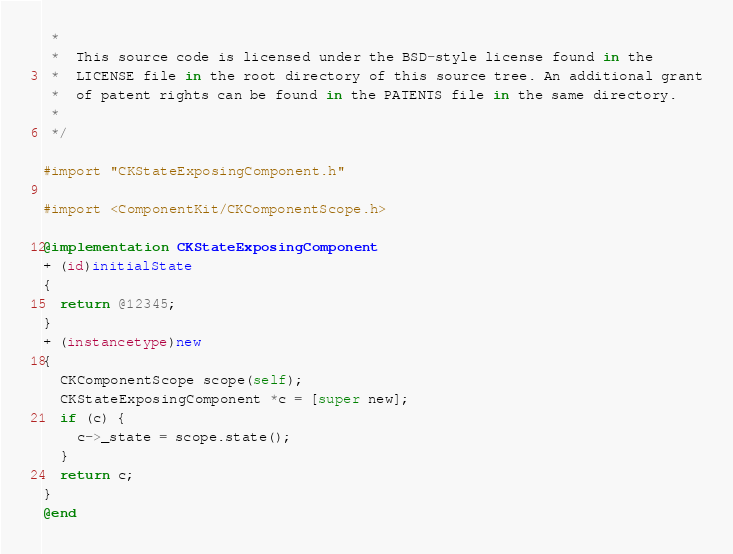<code> <loc_0><loc_0><loc_500><loc_500><_ObjectiveC_> *
 *  This source code is licensed under the BSD-style license found in the
 *  LICENSE file in the root directory of this source tree. An additional grant
 *  of patent rights can be found in the PATENTS file in the same directory.
 *
 */

#import "CKStateExposingComponent.h"

#import <ComponentKit/CKComponentScope.h>

@implementation CKStateExposingComponent
+ (id)initialState
{
  return @12345;
}
+ (instancetype)new
{
  CKComponentScope scope(self);
  CKStateExposingComponent *c = [super new];
  if (c) {
    c->_state = scope.state();
  }
  return c;
}
@end
</code> 